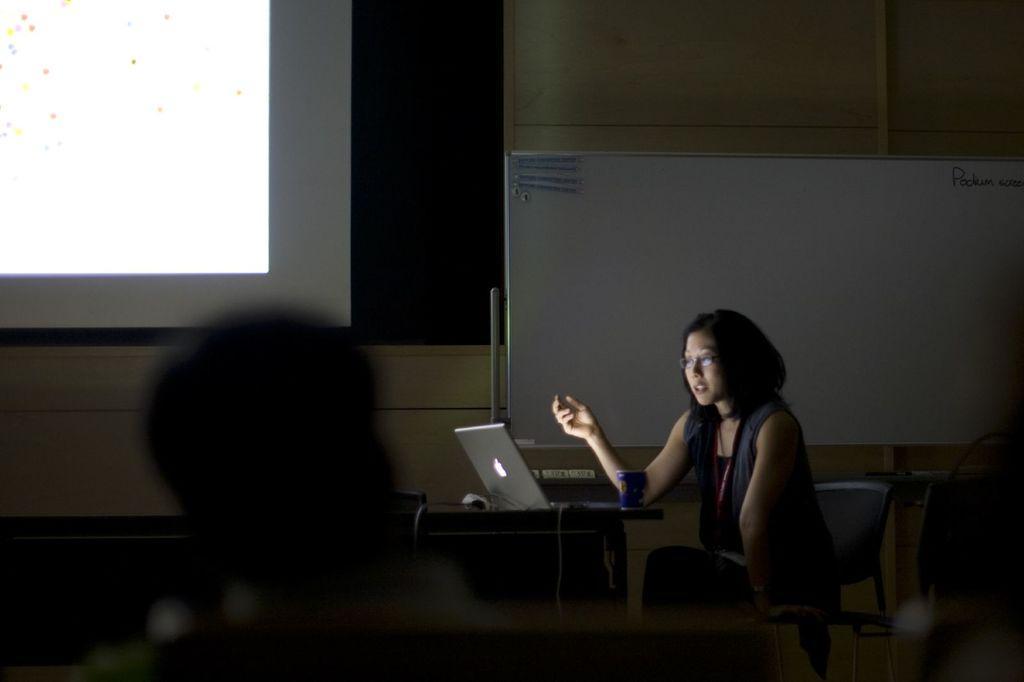Describe this image in one or two sentences. This is an inside view of a room. On the right side, I can see a woman is sitting on the chair and looking into the laptop which is placed on the table. On the left side, I can see a person's head. At the back of this woman I can see a white color board. In the background there is a wall and a window. 